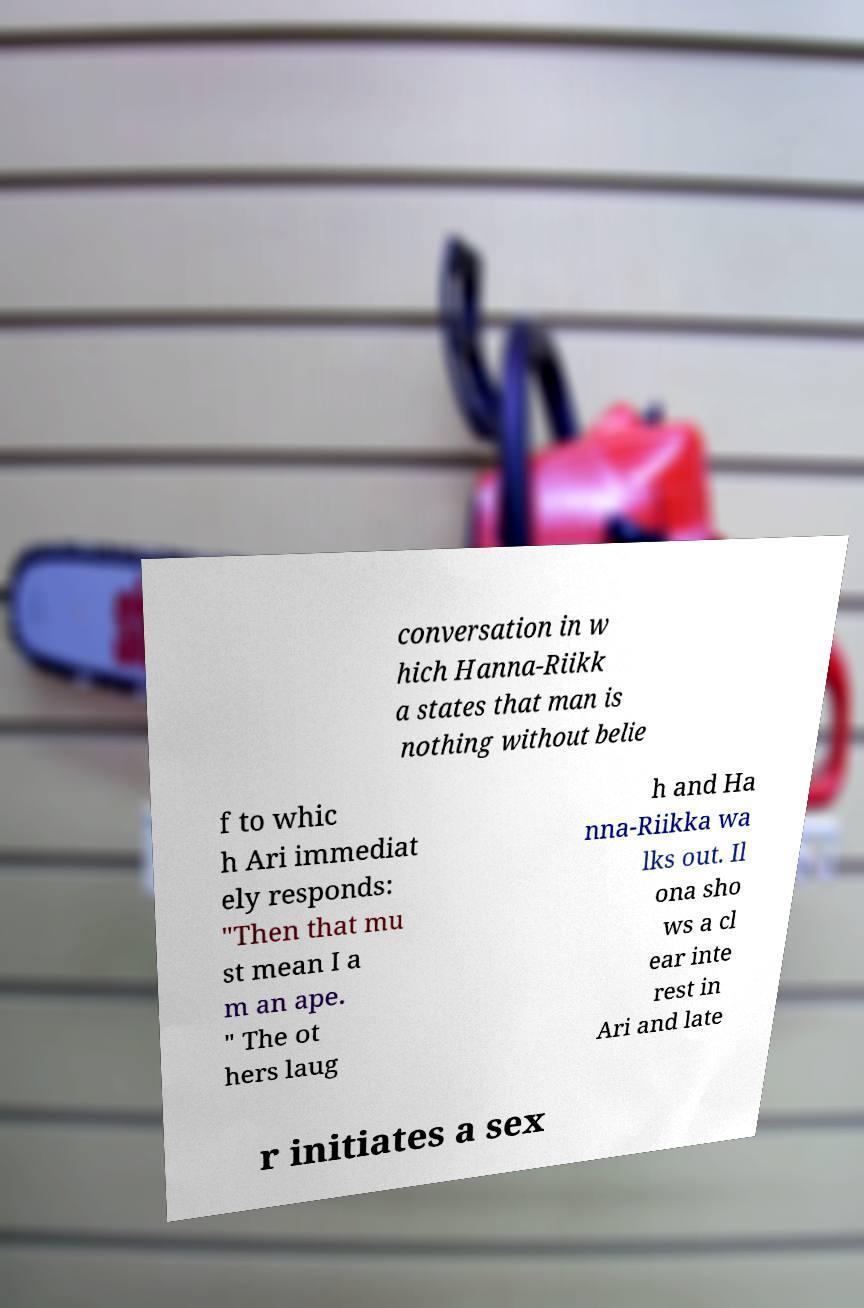Please read and relay the text visible in this image. What does it say? conversation in w hich Hanna-Riikk a states that man is nothing without belie f to whic h Ari immediat ely responds: "Then that mu st mean I a m an ape. " The ot hers laug h and Ha nna-Riikka wa lks out. Il ona sho ws a cl ear inte rest in Ari and late r initiates a sex 